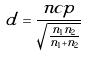Convert formula to latex. <formula><loc_0><loc_0><loc_500><loc_500>\tilde { d } = \frac { n c p } { \sqrt { \frac { n _ { 1 } n _ { 2 } } { n _ { 1 } + n _ { 2 } } } }</formula> 